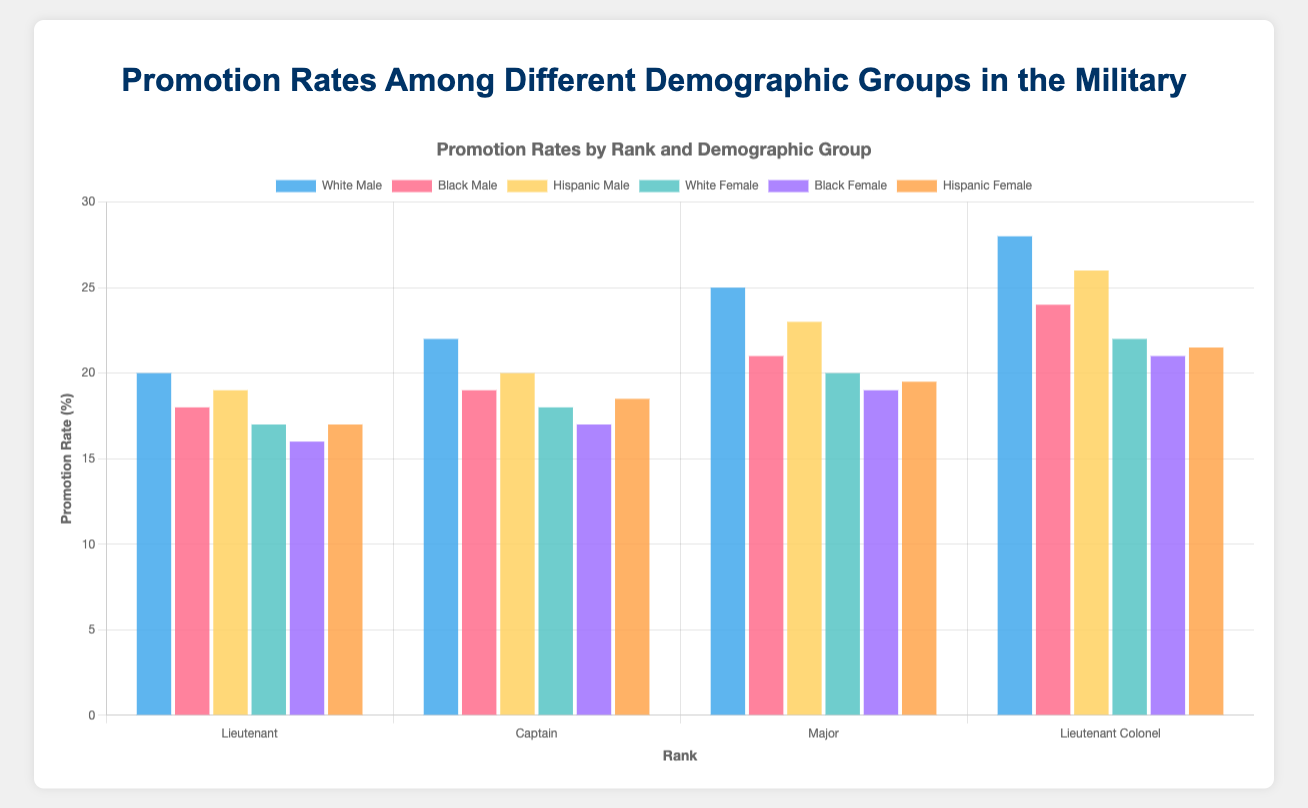Which demographic group has the highest promotion rate for the rank of Captain? To find the group with the highest promotion rate for Captains, look at the "Captain" section and compare the promotion rates of all demographic groups. The "White Male" group has the highest rate at 22%.
Answer: White Male Which gender has a higher average promotion rate for Majors? First, find the average promotion rate for males and females within the rank of Major. For males (White, Black, Hispanic), the rates are 25, 21, and 23, and the average is (25+21+23)/3 ≈ 23. For females (White, Black, Hispanic), the rates are 20, 19, and 19.5, and the average is (20+19+19.5)/3 ≈ 19.5. Males have a higher average promotion rate for Majors.
Answer: Male What is the difference in average years for promotion to Lieutenant Colonel between White Females and Black Males? For White Females, the average years for promotion is 11.5. For Black Males, it is 11. The difference is 11.5 - 11 = 0.5 years.
Answer: 0.5 years Which group among Lieutenants has the shortest average years for promotion? For Lieutenants, compare the average years for promotion across all groups. The shortest time is for White Males, with 3 years.
Answer: White Male How does the promotion rate of Hispanic Females compare to Black Females for the rank of Lieutenant? For Lieutenants, the promotion rates of Hispanic Females and Black Females are 17% and 16%, respectively. Hispanic Females have a slightly higher promotion rate.
Answer: Hispanic Females What is the average promotion rate for White Females across all ranks? Calculate the promotion rate for White Females at each rank and then find the average. Rates: Lieutenant (17), Captain (18), Major (20), Lieutenant Colonel (22). The average is (17+18+20+22)/4 = 19.25.
Answer: 19.25% Which rank experiences the highest promotion rate for Black Males? Compare the promotion rates of Black Males across all ranks: Lieutenant (18), Captain (19), Major (21), Lieutenant Colonel (24). The highest promotion rate is at the rank of Lieutenant Colonel, 24%.
Answer: Lieutenant Colonel Are there any demographic groups that have the same promotion rate for a specific rank? Compare the promotion rates within each rank. For Lieutenants, White Females and Hispanic Females both have a promotion rate of 17%.
Answer: Yes, White Females and Hispanic Females for Lieutenants What is the difference in promotion rate between Hispanic Males and Hispanic Females for the rank of Major? For Majors, the promotion rates for Hispanic Males and Hispanic Females are 23% and 19.5%, respectively. The difference is 23 - 19.5 = 3.5%.
Answer: 3.5% Which demographic group has the slowest average years for promotion to Major? Compare the average years for promotion to Major across all demographic groups. The slowest is Black Females, with 8.2 years.
Answer: Black Female 